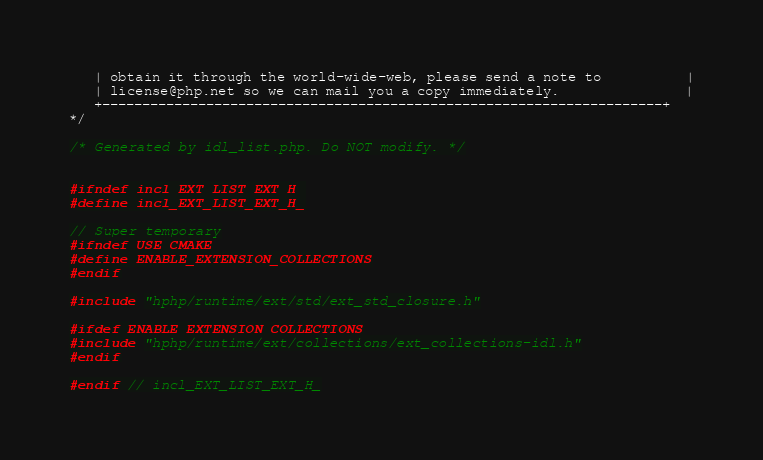<code> <loc_0><loc_0><loc_500><loc_500><_C_>   | obtain it through the world-wide-web, please send a note to          |
   | license@php.net so we can mail you a copy immediately.               |
   +----------------------------------------------------------------------+
*/

/* Generated by idl_list.php. Do NOT modify. */


#ifndef incl_EXT_LIST_EXT_H_
#define incl_EXT_LIST_EXT_H_

// Super temporary
#ifndef USE_CMAKE
#define ENABLE_EXTENSION_COLLECTIONS
#endif

#include "hphp/runtime/ext/std/ext_std_closure.h"

#ifdef ENABLE_EXTENSION_COLLECTIONS
#include "hphp/runtime/ext/collections/ext_collections-idl.h"
#endif

#endif // incl_EXT_LIST_EXT_H_
</code> 